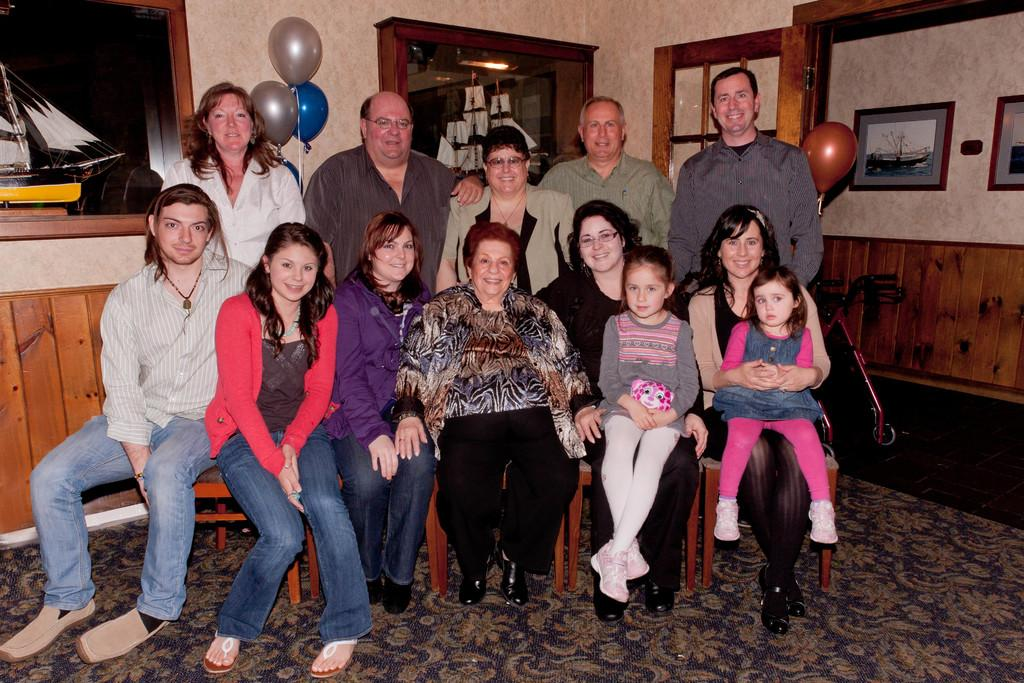What can be found in the room? There are people in the room, and balloons are present in the room. What else can be seen on the walls? There are photo frames on the walls. What type of key is used to unlock the fear in the room? There is no mention of a key or fear in the room; the image only shows people, balloons, and photo frames on the walls. 